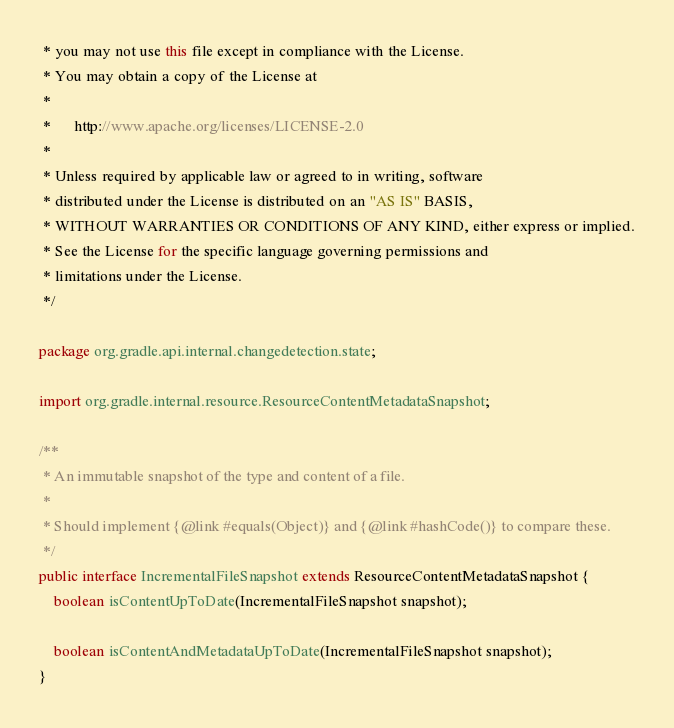Convert code to text. <code><loc_0><loc_0><loc_500><loc_500><_Java_> * you may not use this file except in compliance with the License.
 * You may obtain a copy of the License at
 *
 *      http://www.apache.org/licenses/LICENSE-2.0
 *
 * Unless required by applicable law or agreed to in writing, software
 * distributed under the License is distributed on an "AS IS" BASIS,
 * WITHOUT WARRANTIES OR CONDITIONS OF ANY KIND, either express or implied.
 * See the License for the specific language governing permissions and
 * limitations under the License.
 */

package org.gradle.api.internal.changedetection.state;

import org.gradle.internal.resource.ResourceContentMetadataSnapshot;

/**
 * An immutable snapshot of the type and content of a file.
 *
 * Should implement {@link #equals(Object)} and {@link #hashCode()} to compare these.
 */
public interface IncrementalFileSnapshot extends ResourceContentMetadataSnapshot {
    boolean isContentUpToDate(IncrementalFileSnapshot snapshot);

    boolean isContentAndMetadataUpToDate(IncrementalFileSnapshot snapshot);
}
</code> 